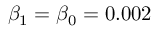<formula> <loc_0><loc_0><loc_500><loc_500>\beta _ { 1 } = \beta _ { 0 } = 0 . 0 0 2</formula> 